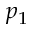Convert formula to latex. <formula><loc_0><loc_0><loc_500><loc_500>p _ { 1 }</formula> 